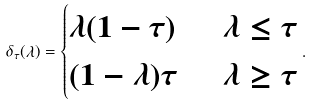Convert formula to latex. <formula><loc_0><loc_0><loc_500><loc_500>\delta _ { \tau } ( \lambda ) = \begin{cases} \lambda ( 1 - \tau ) \ & \ \lambda \leq \tau \\ ( 1 - \lambda ) \tau \ & \ \lambda \geq \tau \end{cases} .</formula> 